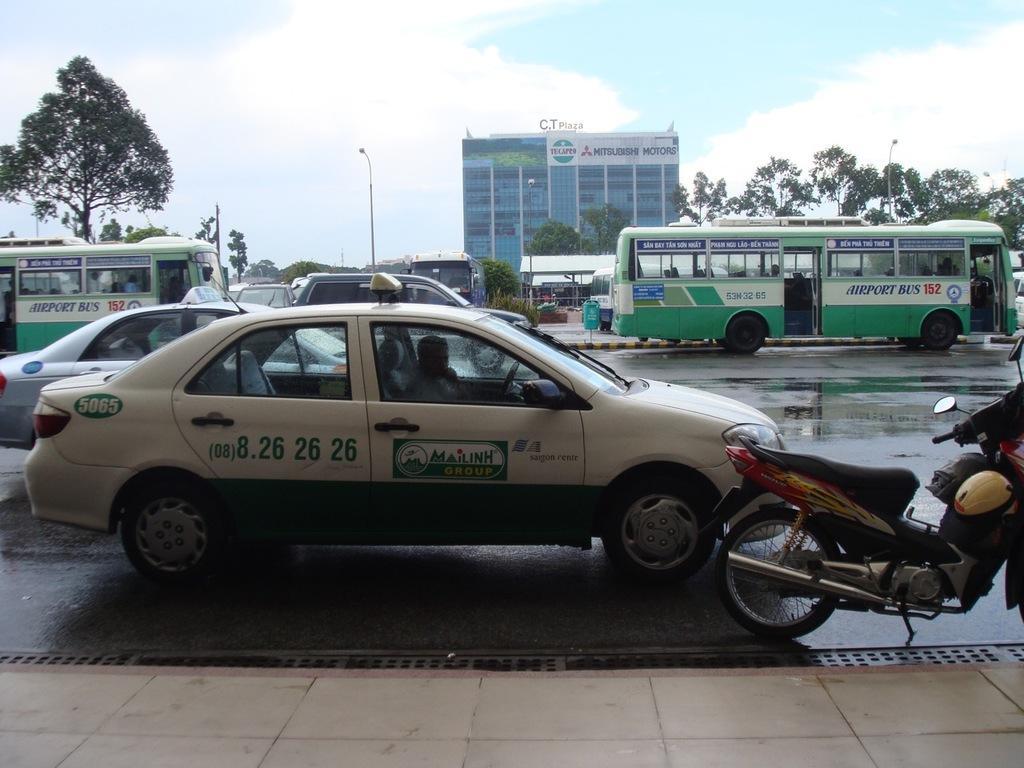How would you summarize this image in a sentence or two? In this image we can see a group of vehicles and we can see persons in few vehicles. Behind the vehicles we can see a building, street poles and a group of trees. At the top we can see the sky. 